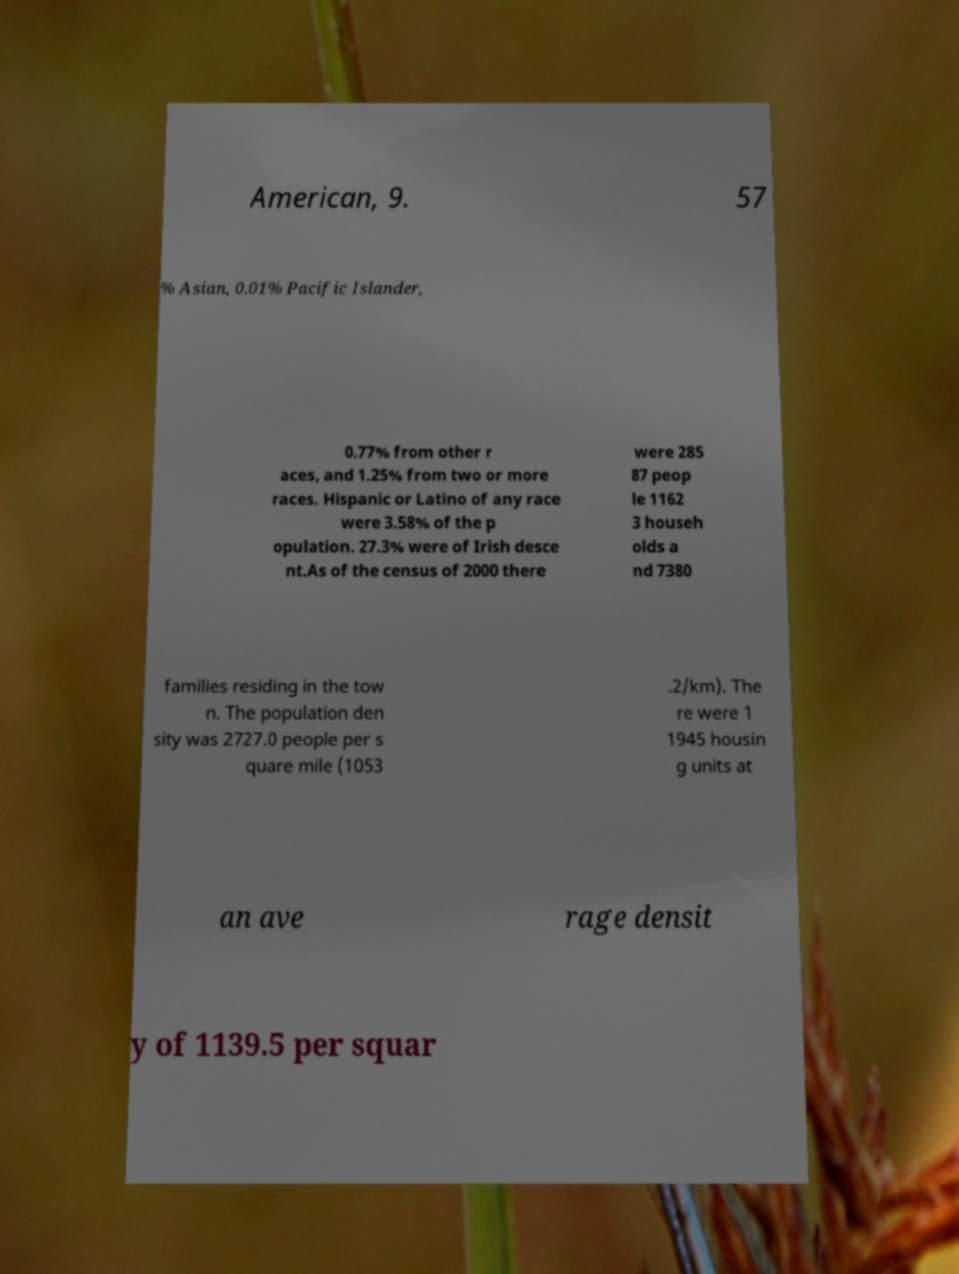Can you read and provide the text displayed in the image?This photo seems to have some interesting text. Can you extract and type it out for me? American, 9. 57 % Asian, 0.01% Pacific Islander, 0.77% from other r aces, and 1.25% from two or more races. Hispanic or Latino of any race were 3.58% of the p opulation. 27.3% were of Irish desce nt.As of the census of 2000 there were 285 87 peop le 1162 3 househ olds a nd 7380 families residing in the tow n. The population den sity was 2727.0 people per s quare mile (1053 .2/km). The re were 1 1945 housin g units at an ave rage densit y of 1139.5 per squar 